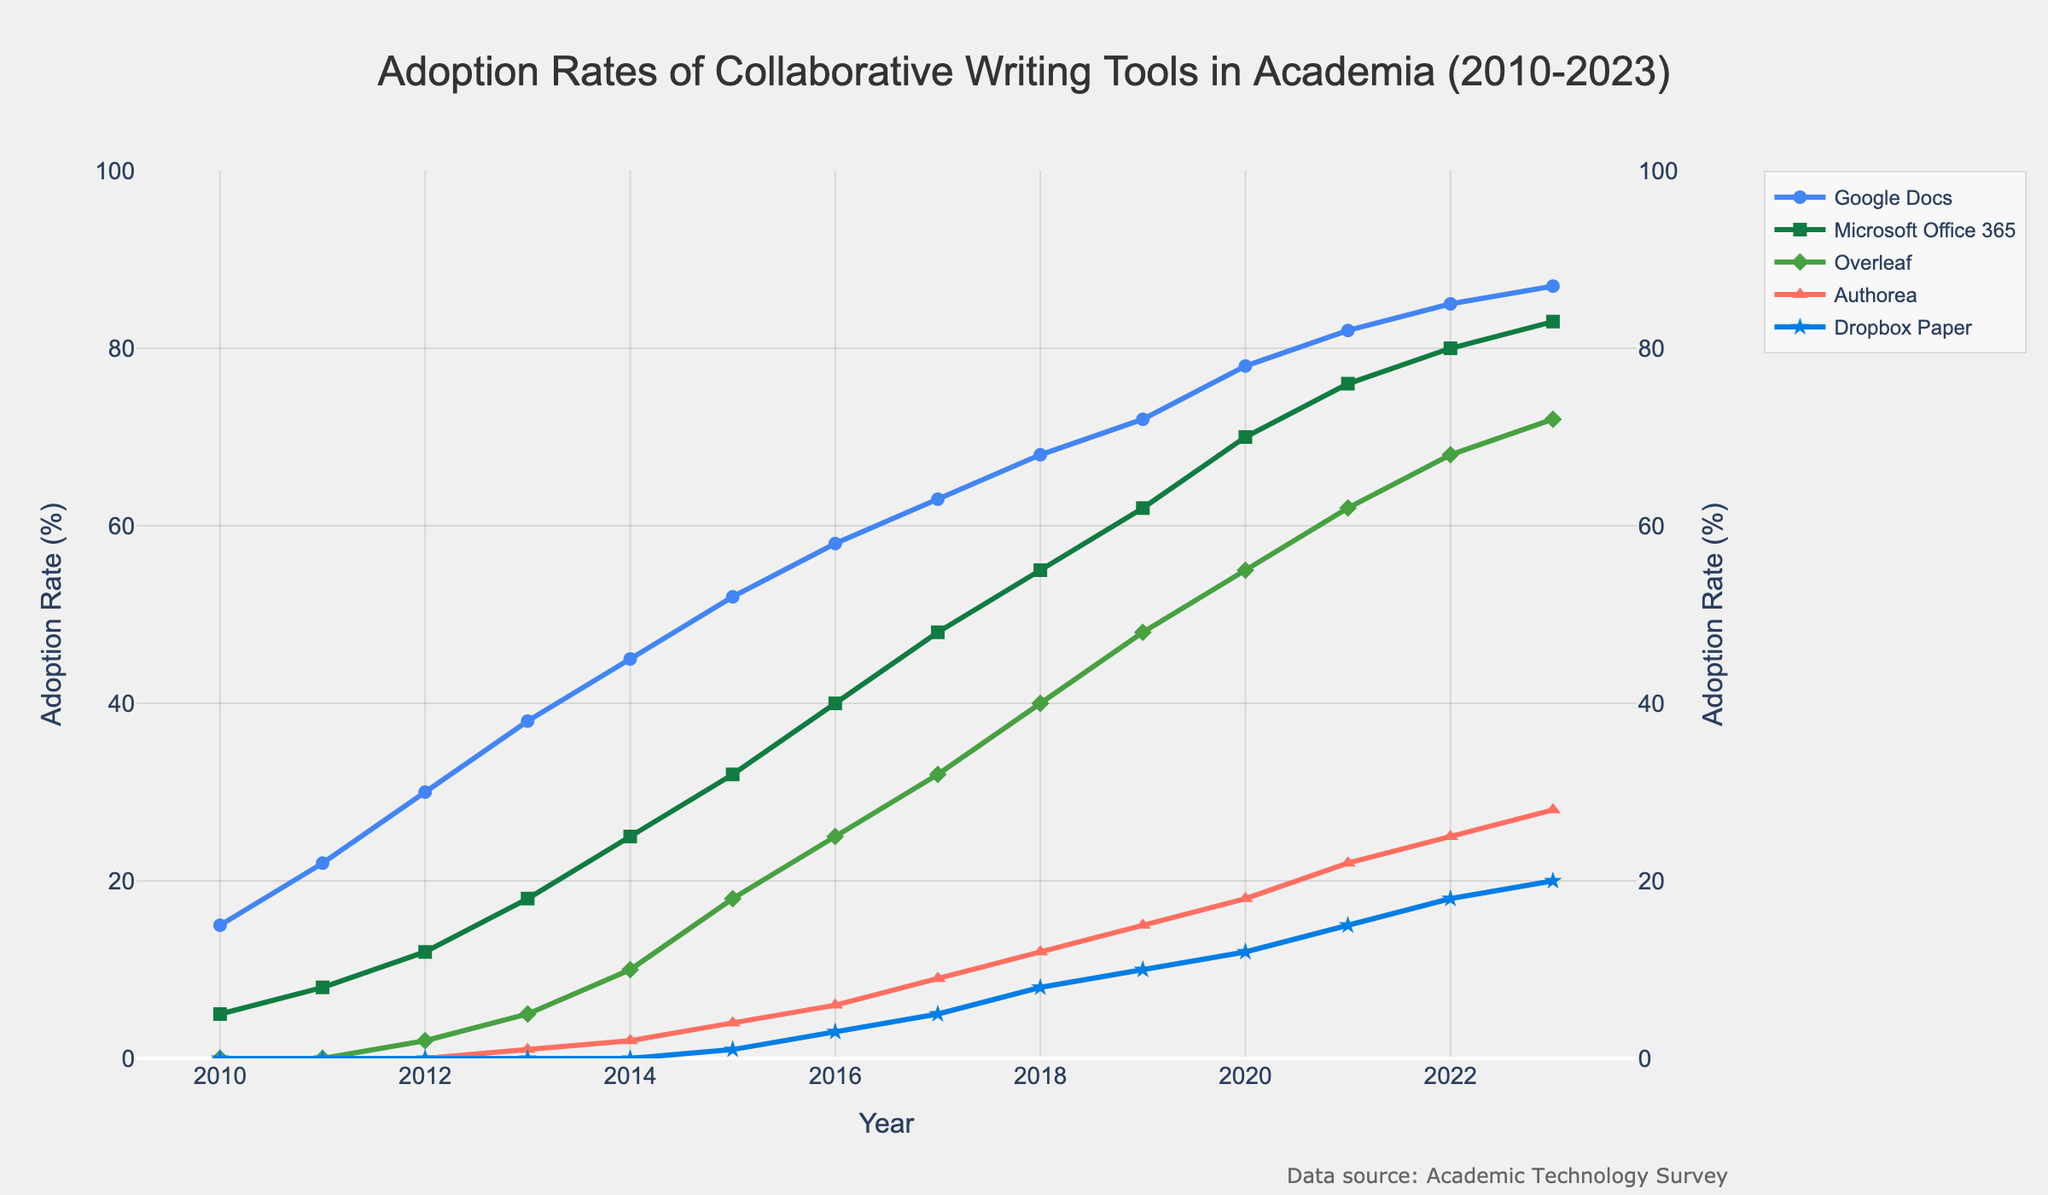At which year did "Overleaf" first appear in the adoption data? To determine the year "Overleaf" first appears, look along its series to where it has the initial non-zero value. According to the chart, "Overleaf" starts appearing in 2012.
Answer: 2012 Which tool had the highest adoption rate in 2021? The highest adoption rate in 2021 is determined by visually comparing the heights of the lines for all tools. "Google Docs" has the highest line in 2021, indicating it had the highest adoption rate.
Answer: Google Docs By how much did the adoption rate of "Authorea" increase from 2015 to 2020? To find the increase, subtract the 2015 value of "Authorea" from its 2020 value. The chart shows "Authorea" at 4% in 2015 and 18% in 2020, resulting in an increase of 18 - 4 = 14%.
Answer: 14% Between "Google Docs" and "Microsoft Office 365", which had a higher growth rate from 2010 to 2023? Calculate the growth rate by subtracting the 2010 adoption rate from the 2023 rate for both tools. "Google Docs" increased from 15% to 87% (72%), and "Microsoft Office 365" from 5% to 83% (78%). "Microsoft Office 365" has a higher growth rate.
Answer: Microsoft Office 365 What was the average adoption rate of "Dropbox Paper" from 2018 to 2023? To find the average, sum the adoption rates for "Dropbox Paper" for each year from 2018 to 2023 and divide by the number of years. The values are 8, 10, 12, 15, 18, 20. The sum is 83, and there are 6 years, so the average is 83/6 ≈ 13.83%.
Answer: 13.83% In what year did "Microsoft Office 365" surpass a 50% adoption rate? Identify where the line for "Microsoft Office 365" crosses the 50% mark by locating the corresponding year in the chart. The chart shows this occurs in 2018.
Answer: 2018 Which tool had the lowest adoption rate in 2013? Compare the heights of the lines for each tool in 2013. "Authorea" is the lowest, indicating it had the lowest adoption rate.
Answer: Authorea What is the combined adoption rate of "Google Docs" and "Overleaf" in 2023? Add the adoption rates of "Google Docs" and "Overleaf" for 2023. "Google Docs" has an adoption rate of 87% and "Overleaf" 72%, so the combined rate is 87 + 72 = 159%.
Answer: 159% How did the adoption rate of "Dropbox Paper" change from 2016 to 2023? Calculate the change by subtracting the 2016 value of "Dropbox Paper" from its 2023 value. In 2016 it was 3%, and in 2023 it was 20%, so the increase is 20 - 3 = 17%.
Answer: 17% Which tool had the steepest increase in adoption between 2020 and 2021? Identify the tool with the most significant slope change between 2020 and 2021 by comparing the adoption rate differences. "Authorea" increased from 18% to 22%, which is a 4% change, the highest of any tool between those years.
Answer: Authorea 